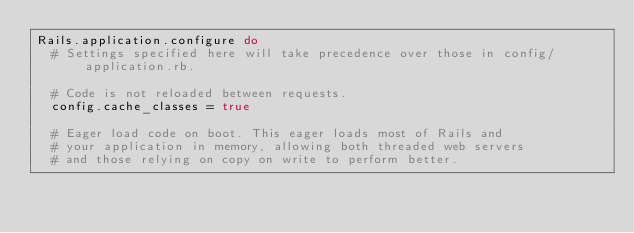Convert code to text. <code><loc_0><loc_0><loc_500><loc_500><_Ruby_>Rails.application.configure do
  # Settings specified here will take precedence over those in config/application.rb.

  # Code is not reloaded between requests.
  config.cache_classes = true

  # Eager load code on boot. This eager loads most of Rails and
  # your application in memory, allowing both threaded web servers
  # and those relying on copy on write to perform better.</code> 